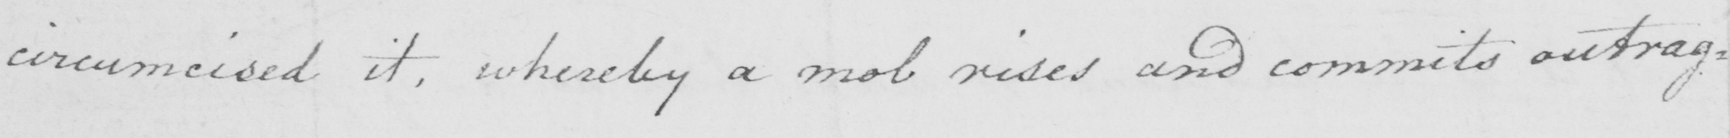Please provide the text content of this handwritten line. circumcised it , whereby a mob rises and commits outrag= 